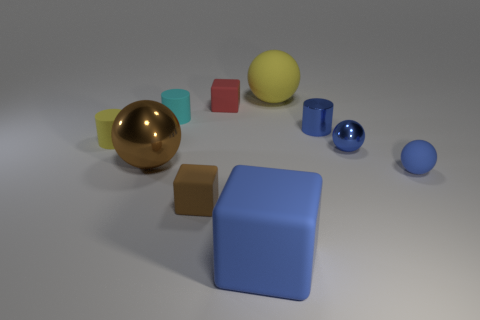Subtract all brown metallic spheres. How many spheres are left? 3 Subtract all cyan blocks. How many blue spheres are left? 2 Subtract all red cubes. How many cubes are left? 2 Subtract 1 cubes. How many cubes are left? 2 Subtract all balls. How many objects are left? 6 Subtract all green blocks. Subtract all blue cylinders. How many blocks are left? 3 Subtract all big brown objects. Subtract all yellow rubber balls. How many objects are left? 8 Add 1 small blue spheres. How many small blue spheres are left? 3 Add 3 big blue rubber blocks. How many big blue rubber blocks exist? 4 Subtract 1 blue cubes. How many objects are left? 9 